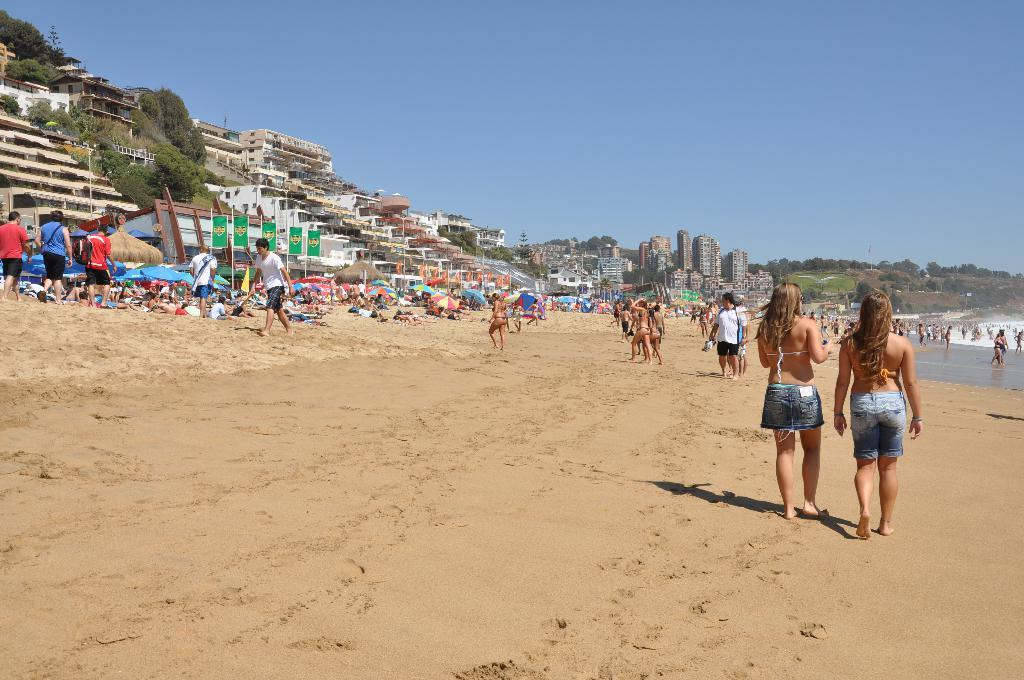What type of location is depicted in the image? The image contains a beach. Are there any people in the image? Yes, there are people present in the image. What can be seen on the ground in the image? The ground is visible in the image. What type of shelter is present in the image? There is an umbrella in the image. What architectural features can be seen in the image? Poles and buildings with windows are present in the image. What additional objects can be seen in the image? Flags and trees are present in the image. What part of the natural environment is visible in the image? The sky is visible in the image. What type of leather material can be seen on the cushion in the image? There is no leather or cushion present in the image. 